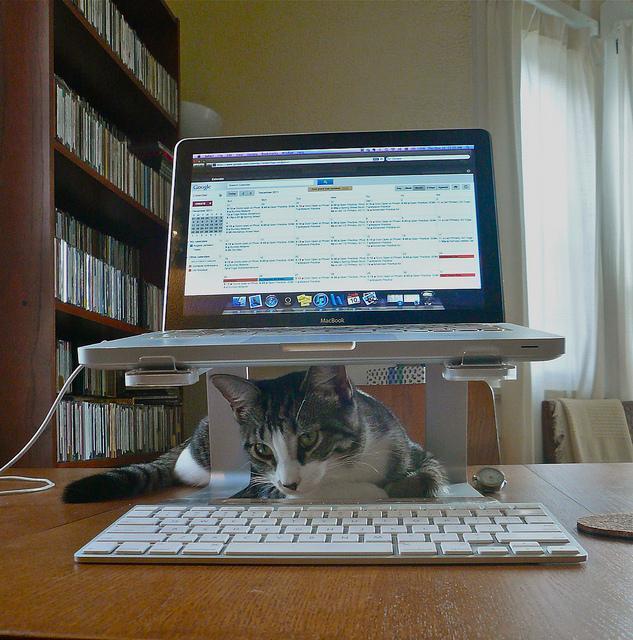How many laptops are visible?
Give a very brief answer. 1. 